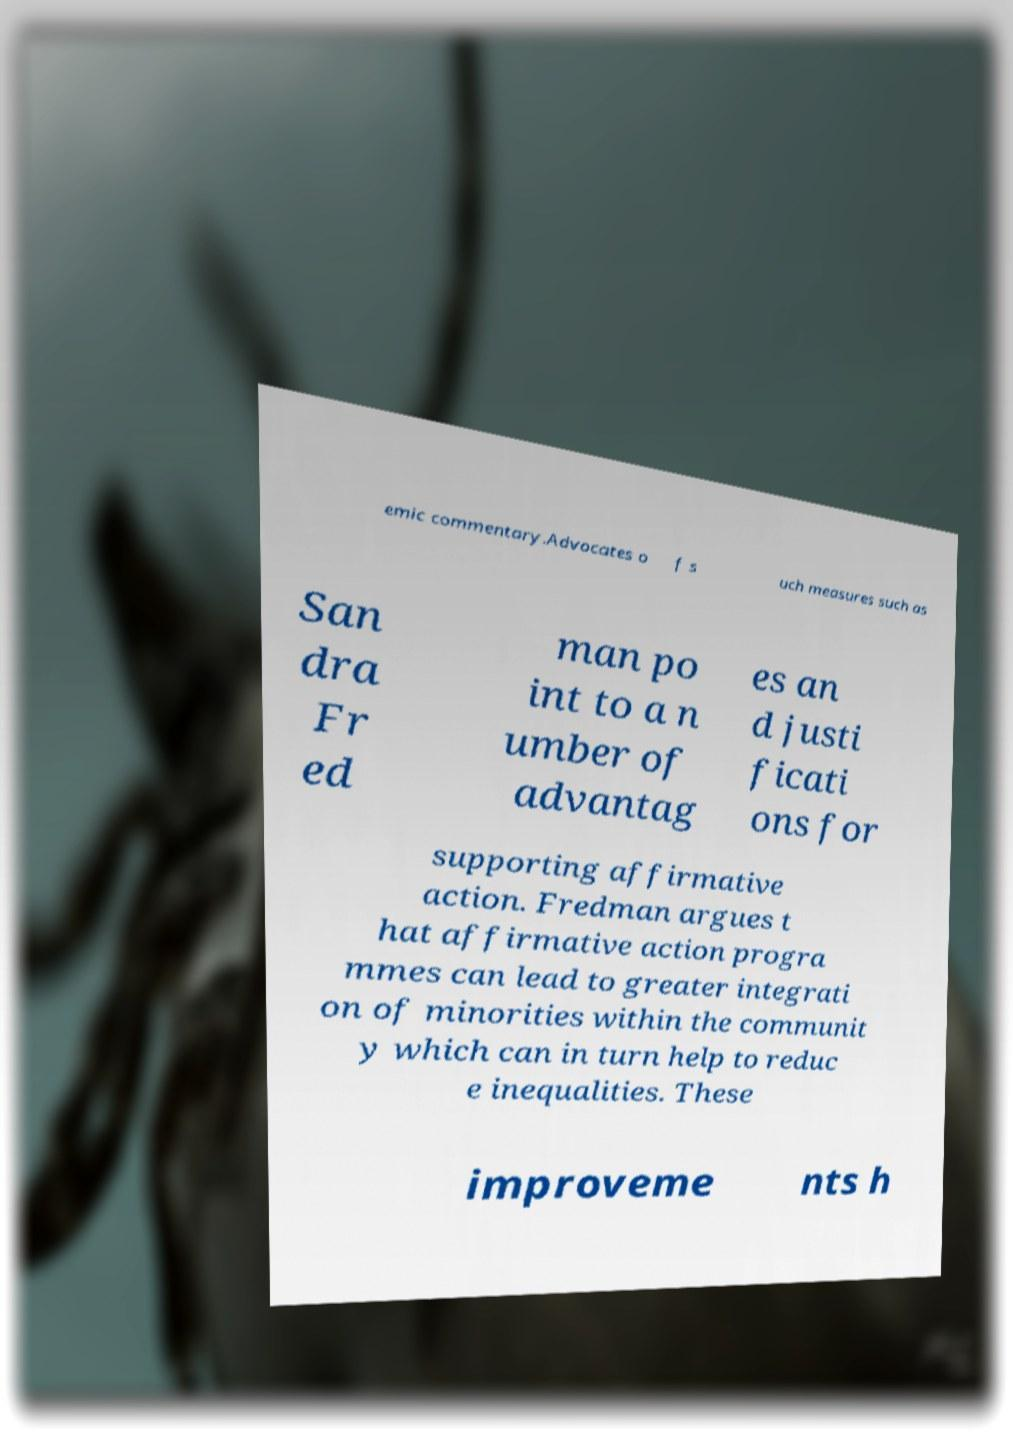I need the written content from this picture converted into text. Can you do that? emic commentary.Advocates o f s uch measures such as San dra Fr ed man po int to a n umber of advantag es an d justi ficati ons for supporting affirmative action. Fredman argues t hat affirmative action progra mmes can lead to greater integrati on of minorities within the communit y which can in turn help to reduc e inequalities. These improveme nts h 